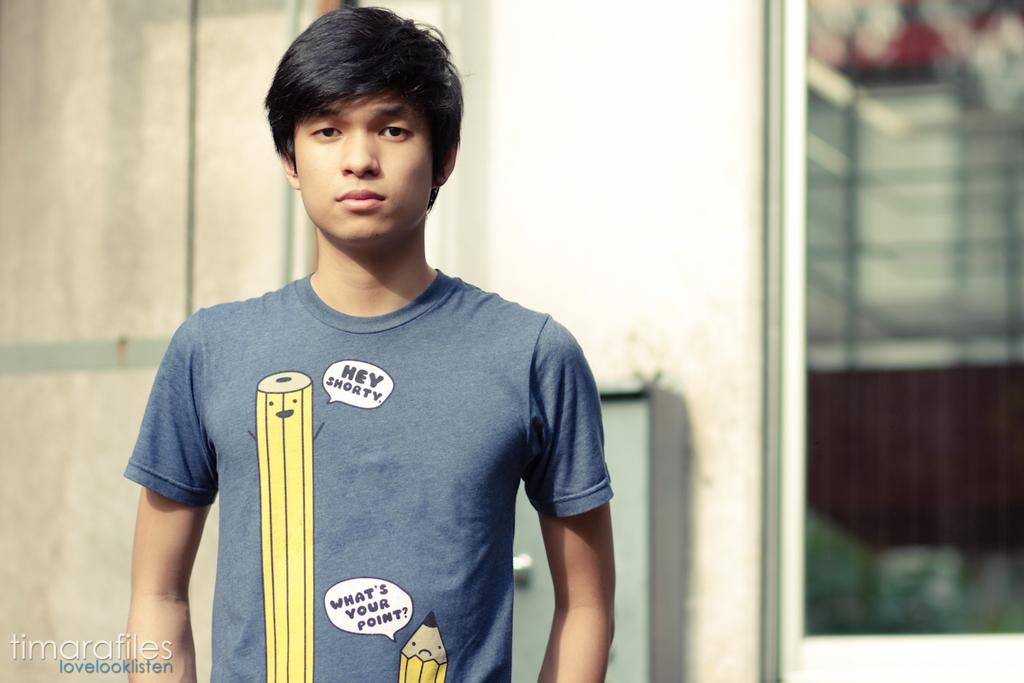Provide a one-sentence caption for the provided image. a boy wearing a shirt that says ' hey shorty' and 'what's your point'. 